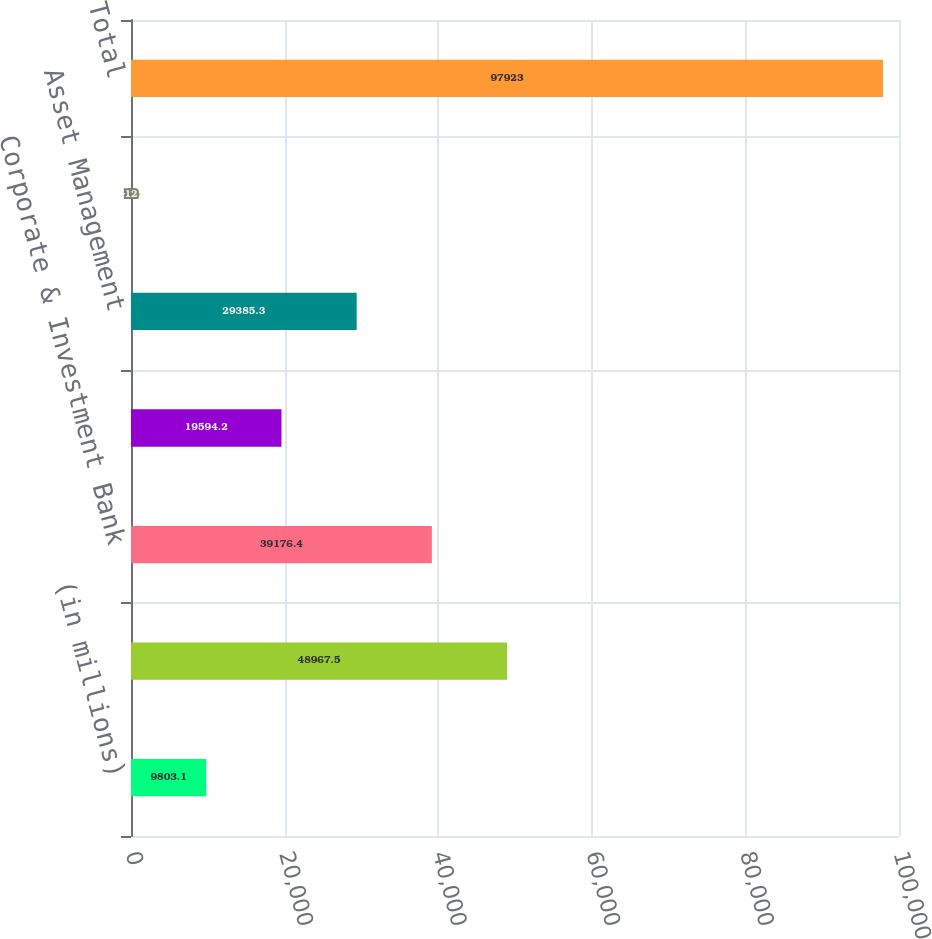<chart> <loc_0><loc_0><loc_500><loc_500><bar_chart><fcel>(in millions)<fcel>Consumer & Community Banking<fcel>Corporate & Investment Bank<fcel>Commercial Banking<fcel>Asset Management<fcel>Corporate<fcel>Total<nl><fcel>9803.1<fcel>48967.5<fcel>39176.4<fcel>19594.2<fcel>29385.3<fcel>12<fcel>97923<nl></chart> 